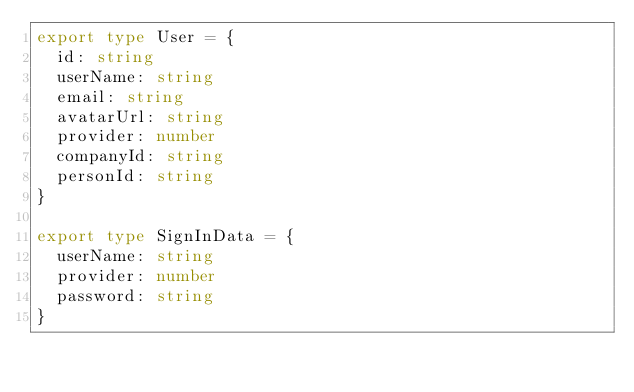Convert code to text. <code><loc_0><loc_0><loc_500><loc_500><_TypeScript_>export type User = {
  id: string
  userName: string
  email: string
  avatarUrl: string
  provider: number
  companyId: string
  personId: string
}

export type SignInData = {
  userName: string
  provider: number
  password: string
}
</code> 